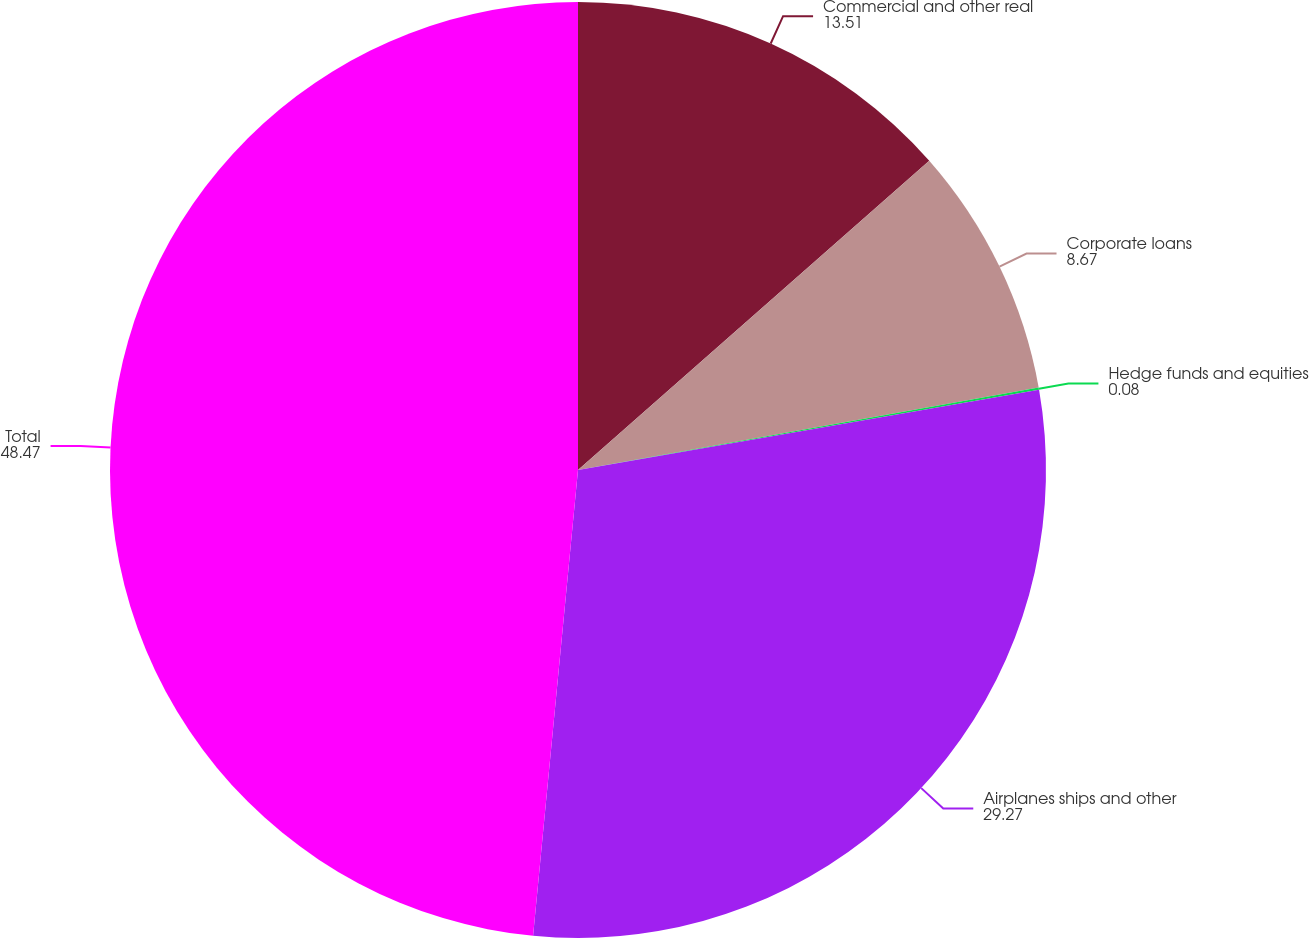Convert chart. <chart><loc_0><loc_0><loc_500><loc_500><pie_chart><fcel>Commercial and other real<fcel>Corporate loans<fcel>Hedge funds and equities<fcel>Airplanes ships and other<fcel>Total<nl><fcel>13.51%<fcel>8.67%<fcel>0.08%<fcel>29.27%<fcel>48.47%<nl></chart> 